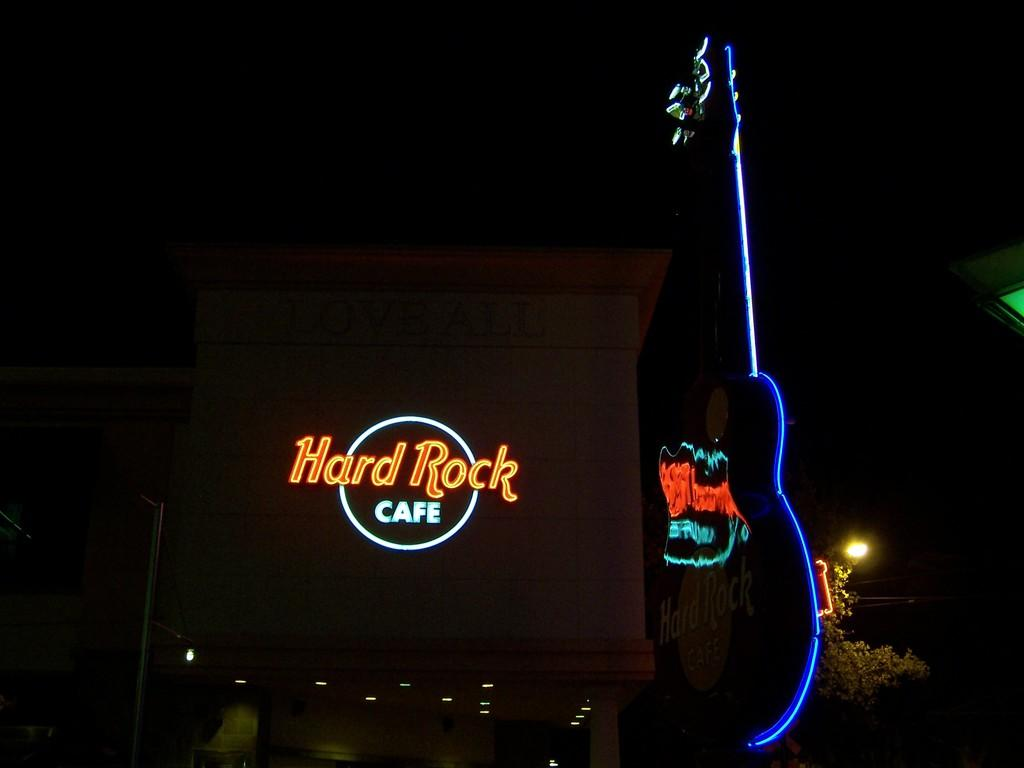What musical instrument is visible in the image? There is a guitar in the image. What can be seen illuminating the scene in the image? There are lights in the image. What type of natural elements are present in the image? There are trees in the image. What structural element is present in the image? There is a pole in the image. What type of signage is present in the image? There is a board with text in the image. Are there any other objects visible in the image? Yes, there are other objects in the image. How would you describe the overall lighting in the image? The background of the image is dark. Can you tell me how many laborers are working on the back of the guitar in the image? There are no laborers present in the image, and the guitar is not depicted as having a back. What type of guide is featured in the image? There is no guide present in the image. 